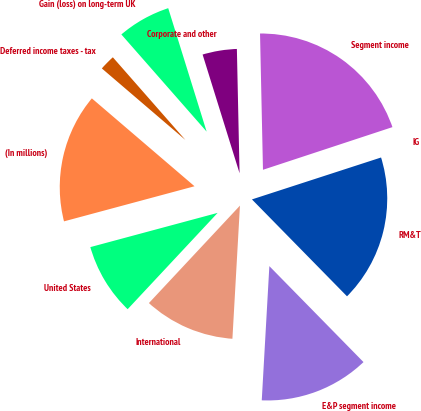Convert chart. <chart><loc_0><loc_0><loc_500><loc_500><pie_chart><fcel>(In millions)<fcel>United States<fcel>International<fcel>E&P segment income<fcel>RM&T<fcel>IG<fcel>Segment income<fcel>Corporate and other<fcel>Gain (loss) on long-term UK<fcel>Deferred income taxes - tax<nl><fcel>15.45%<fcel>8.86%<fcel>11.06%<fcel>13.25%<fcel>17.65%<fcel>0.07%<fcel>20.28%<fcel>4.46%<fcel>6.66%<fcel>2.27%<nl></chart> 